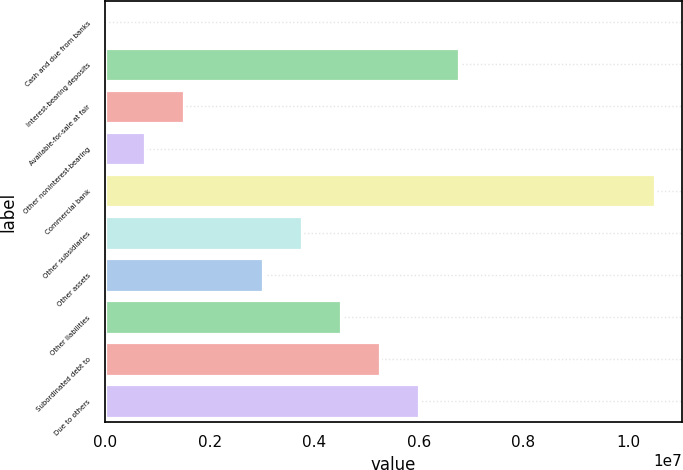<chart> <loc_0><loc_0><loc_500><loc_500><bar_chart><fcel>Cash and due from banks<fcel>Interest-bearing deposits<fcel>Available-for-sale at fair<fcel>Other noninterest-bearing<fcel>Commercial bank<fcel>Other subsidiaries<fcel>Other assets<fcel>Other liabilities<fcel>Subordinated debt to<fcel>Due to others<nl><fcel>18375<fcel>6.7586e+06<fcel>1.5162e+06<fcel>767289<fcel>1.05032e+07<fcel>3.76295e+06<fcel>3.01403e+06<fcel>4.51186e+06<fcel>5.26078e+06<fcel>6.00969e+06<nl></chart> 